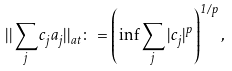<formula> <loc_0><loc_0><loc_500><loc_500>| | \sum _ { j } c _ { j } a _ { j } | | _ { a t } \colon = \left ( \inf \sum _ { j } | c _ { j } | ^ { p } \right ) ^ { 1 / p } ,</formula> 